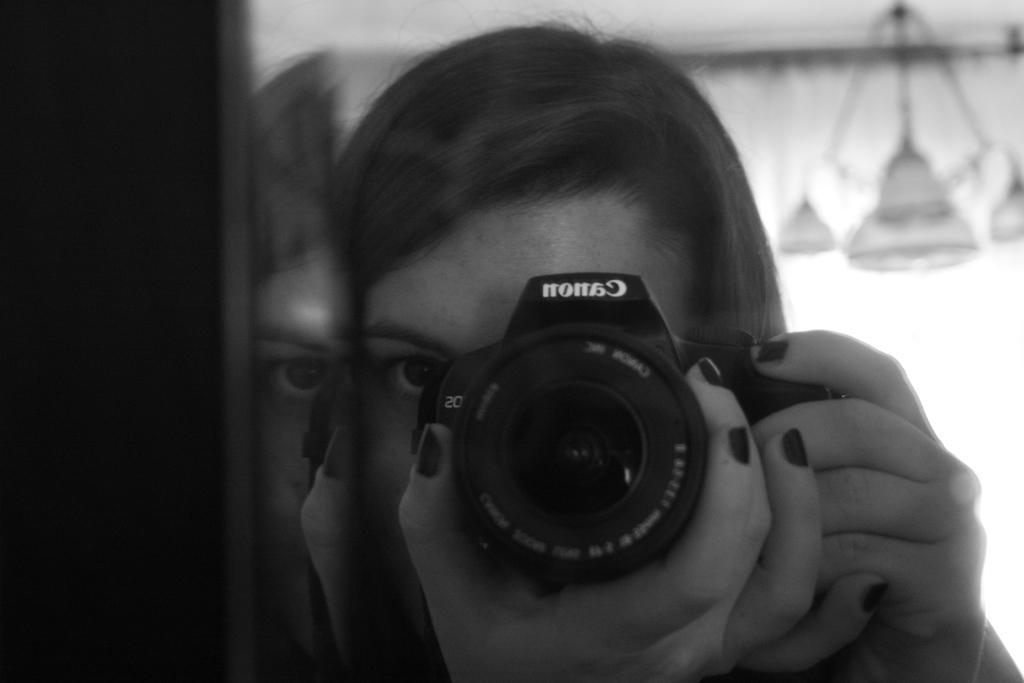Describe this image in one or two sentences. In this image I can see a woman and she is holding a camera. 